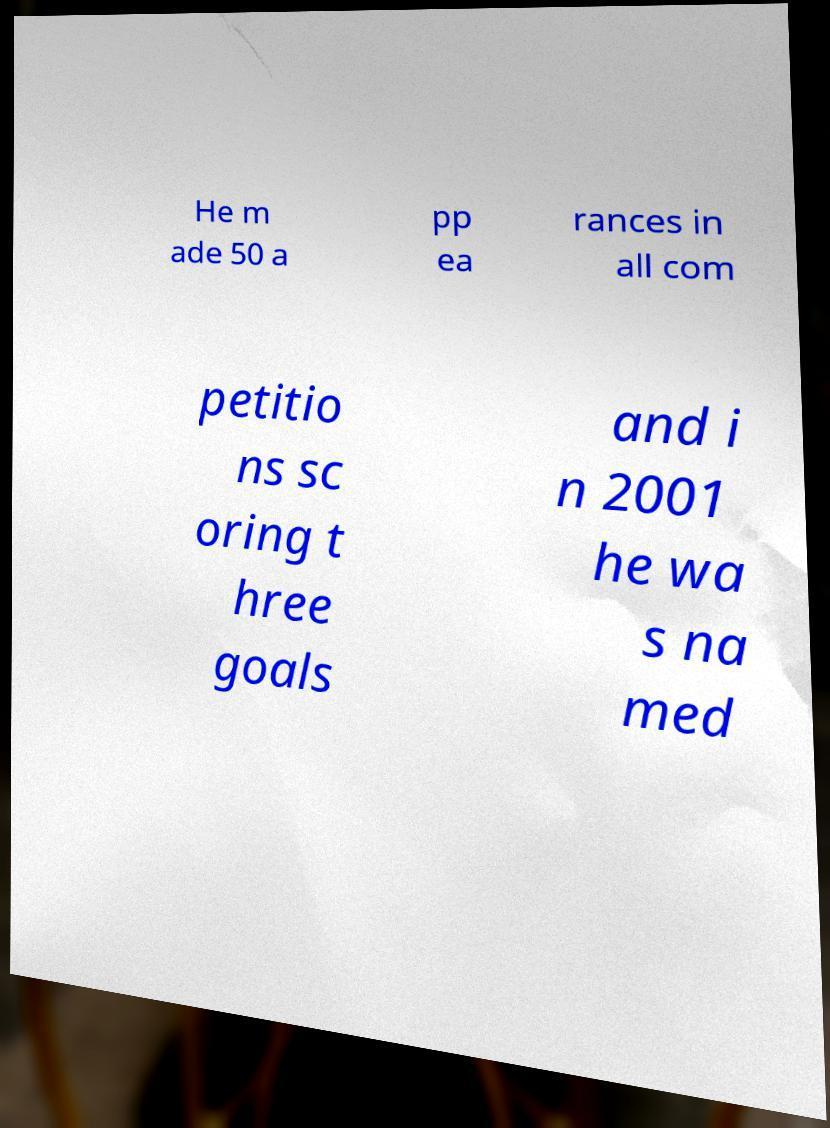For documentation purposes, I need the text within this image transcribed. Could you provide that? He m ade 50 a pp ea rances in all com petitio ns sc oring t hree goals and i n 2001 he wa s na med 